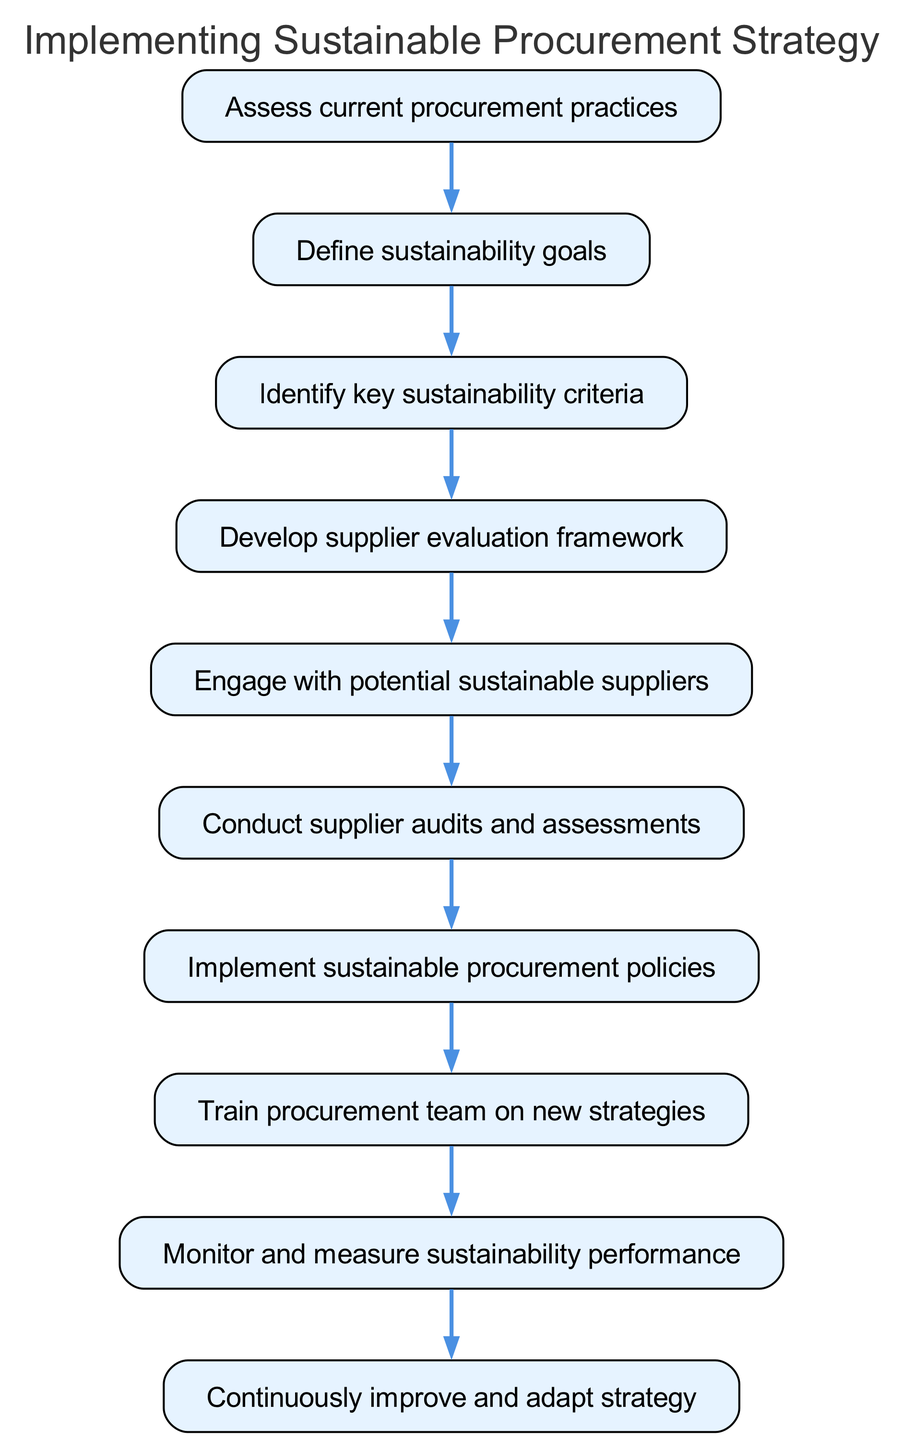What is the first step in the sustainable procurement strategy? The first step listed in the diagram is "Assess current procurement practices," which is the initial action to take when implementing the strategy.
Answer: Assess current procurement practices How many total steps are there in the diagram? The diagram outlines a total of 10 distinct steps from the beginning to the end of the sustainable procurement strategy.
Answer: 10 What step follows "Engage with potential sustainable suppliers"? The next step after "Engage with potential sustainable suppliers" is "Conduct supplier audits and assessments," which is a logical continuation of the supplier engagement process.
Answer: Conduct supplier audits and assessments Which step comes after defining sustainability goals? After defining sustainability goals, the next step is to "Identify key sustainability criteria," indicating that understanding criteria is crucial for setting up goals effectively.
Answer: Identify key sustainability criteria What is the last step in the sustainable procurement strategy? The final step, as indicated in the flow chart, is "Continuously improve and adapt strategy," which emphasizes the need for ongoing refinement of the procurement approach.
Answer: Continuously improve and adapt strategy What is the relationship between step 3 and step 4? Step 3 ("Identify key sustainability criteria") leads directly to step 4 ("Develop supplier evaluation framework"), indicating that identifying criteria is essential for creating an effective evaluation framework.
Answer: Step 3 leads to step 4 What should be done after implementing sustainable procurement policies? Following the implementation of sustainable procurement policies, the procurement team must be "Trained on new strategies" to ensure they understand and can effectively apply the new policies.
Answer: Train procurement team on new strategies How does supplier audits and assessments contribute to the strategy? Conducting "Supplier audits and assessments" allows the organization to evaluate potential suppliers against established sustainability criteria, ensuring that selected suppliers align with sustainability goals.
Answer: Evaluate suppliers against criteria What is the purpose of developing a supplier evaluation framework? The purpose of developing a supplier evaluation framework is to systematically assess potential suppliers based on identified sustainability criteria, facilitating informed decision-making in procurement.
Answer: Systematically assess suppliers What follows the step of monitoring and measuring sustainability performance? "Continuously improve and adapt strategy" follows monitoring and measuring sustainability performance, indicating that ongoing evaluation feeds into strategy refinement.
Answer: Continuously improve and adapt strategy 